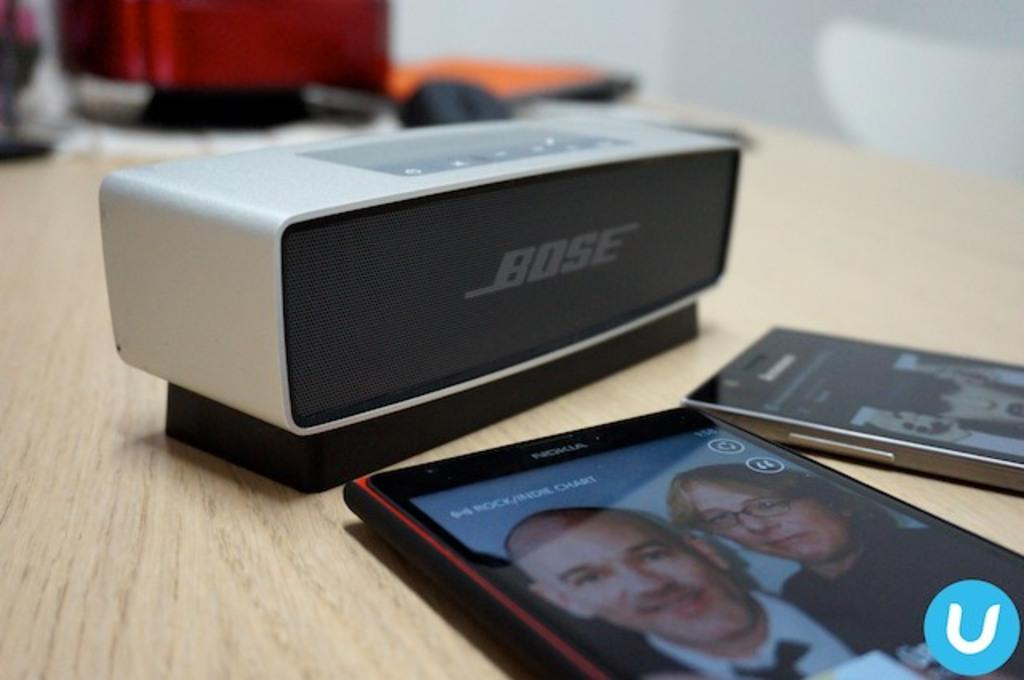What is located at the bottom of the image? There is a table at the bottom of the image. What items can be seen on the table? There are mobile phones and a speaker on the table. Can you describe the background of the image? The background of the image is blurred. How many rabbits are visible in the image? There are no rabbits present in the image. What is the size of the instrument used by the rabbit in the image? There is no instrument or rabbit present in the image. 